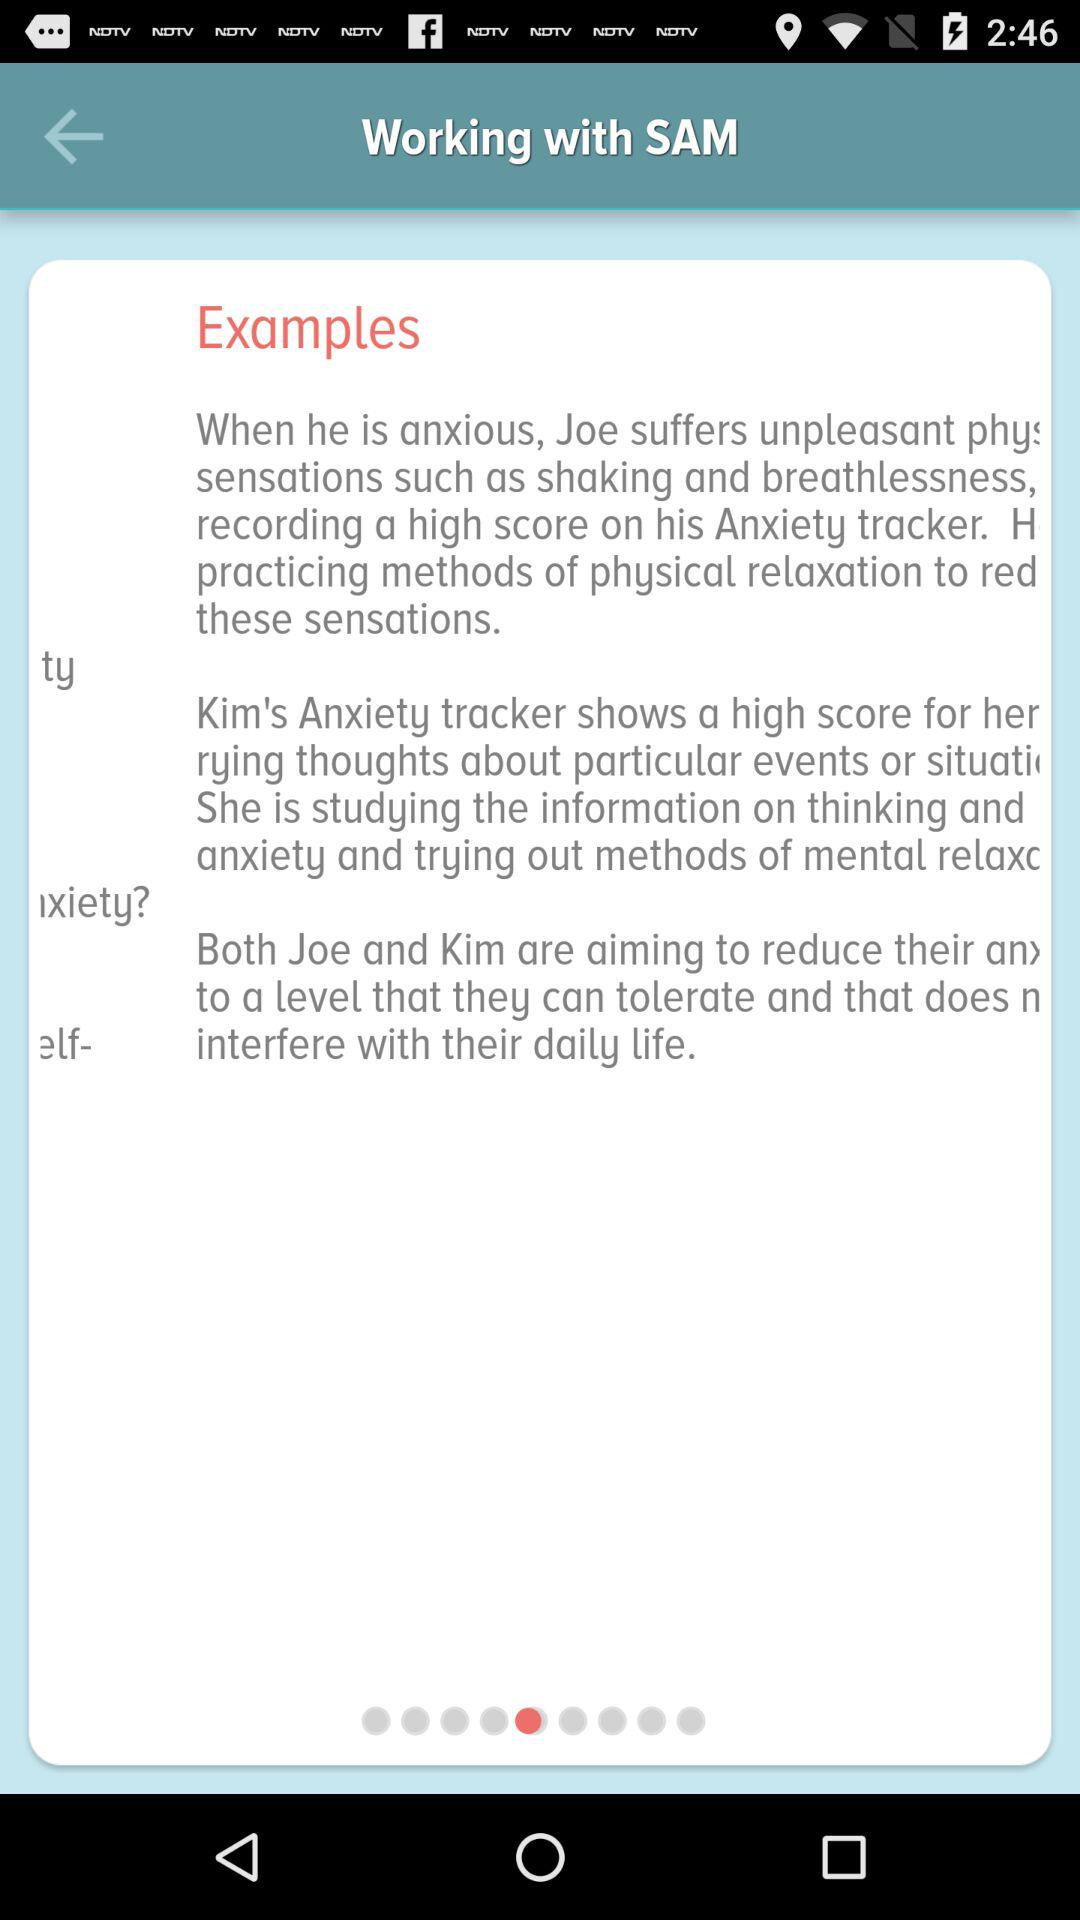Which person is trying to reduce their anxiety by studying information on thinking and anxiety?
Answer the question using a single word or phrase. Kim 